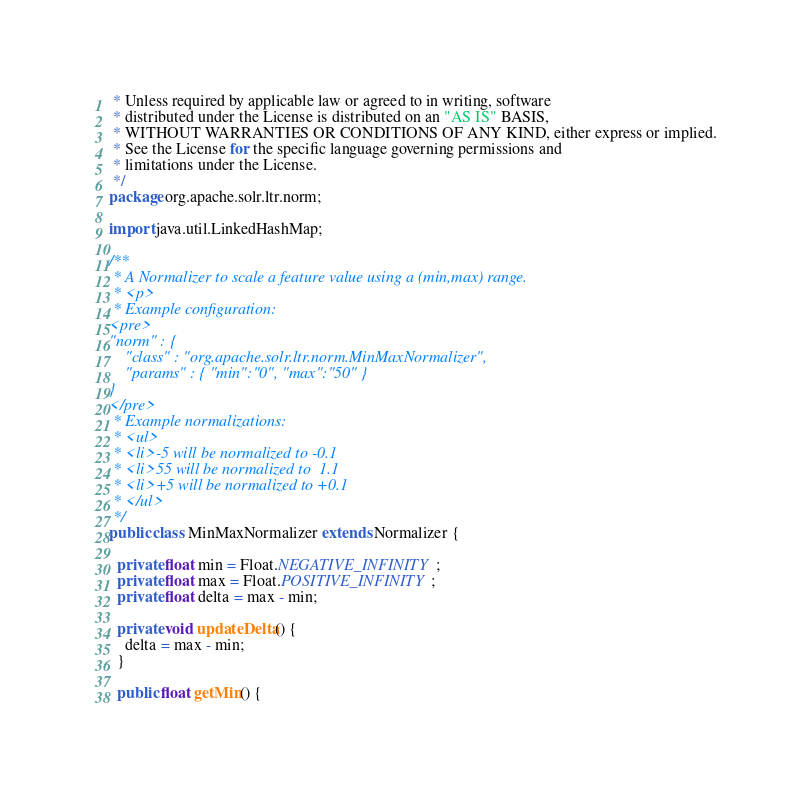Convert code to text. <code><loc_0><loc_0><loc_500><loc_500><_Java_> * Unless required by applicable law or agreed to in writing, software
 * distributed under the License is distributed on an "AS IS" BASIS,
 * WITHOUT WARRANTIES OR CONDITIONS OF ANY KIND, either express or implied.
 * See the License for the specific language governing permissions and
 * limitations under the License.
 */
package org.apache.solr.ltr.norm;

import java.util.LinkedHashMap;

/**
 * A Normalizer to scale a feature value using a (min,max) range.
 * <p>
 * Example configuration:
<pre>
"norm" : {
    "class" : "org.apache.solr.ltr.norm.MinMaxNormalizer",
    "params" : { "min":"0", "max":"50" }
}
</pre>
 * Example normalizations:
 * <ul>
 * <li>-5 will be normalized to -0.1
 * <li>55 will be normalized to  1.1
 * <li>+5 will be normalized to +0.1
 * </ul>
 */
public class MinMaxNormalizer extends Normalizer {

  private float min = Float.NEGATIVE_INFINITY;
  private float max = Float.POSITIVE_INFINITY;
  private float delta = max - min;

  private void updateDelta() {
    delta = max - min;
  }

  public float getMin() {</code> 